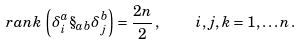<formula> <loc_0><loc_0><loc_500><loc_500>r a n k \, \left ( \delta _ { i } ^ { a } \S _ { a b } \delta _ { j } ^ { b } \right ) = \frac { 2 n } { 2 } \, , \quad i , j , k = 1 , \dots n \, .</formula> 